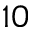<formula> <loc_0><loc_0><loc_500><loc_500>_ { 1 0 }</formula> 